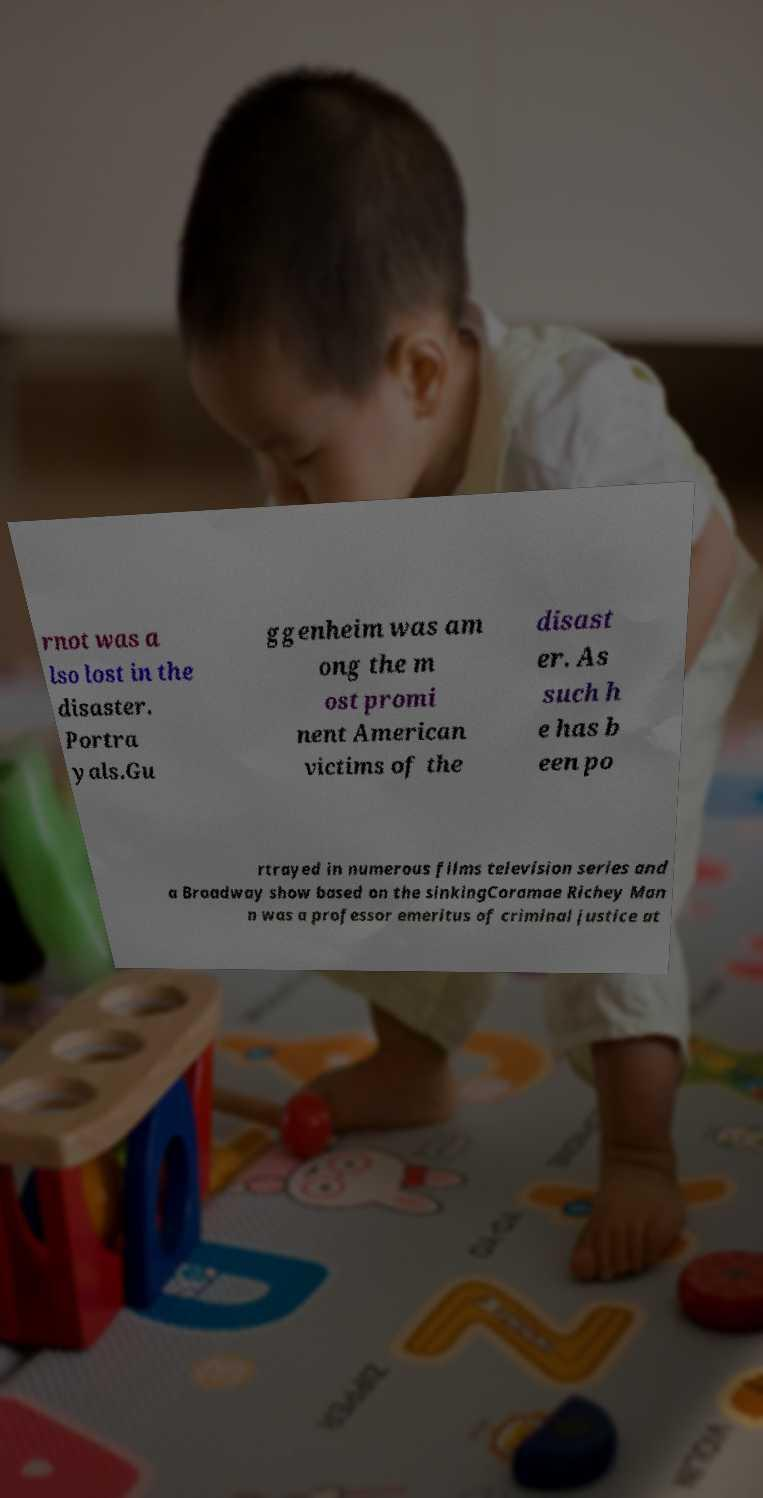Can you read and provide the text displayed in the image?This photo seems to have some interesting text. Can you extract and type it out for me? rnot was a lso lost in the disaster. Portra yals.Gu ggenheim was am ong the m ost promi nent American victims of the disast er. As such h e has b een po rtrayed in numerous films television series and a Broadway show based on the sinkingCoramae Richey Man n was a professor emeritus of criminal justice at 